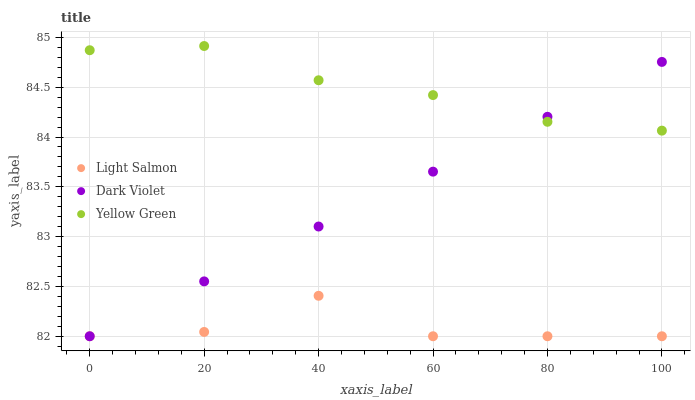Does Light Salmon have the minimum area under the curve?
Answer yes or no. Yes. Does Yellow Green have the maximum area under the curve?
Answer yes or no. Yes. Does Dark Violet have the minimum area under the curve?
Answer yes or no. No. Does Dark Violet have the maximum area under the curve?
Answer yes or no. No. Is Dark Violet the smoothest?
Answer yes or no. Yes. Is Light Salmon the roughest?
Answer yes or no. Yes. Is Yellow Green the smoothest?
Answer yes or no. No. Is Yellow Green the roughest?
Answer yes or no. No. Does Light Salmon have the lowest value?
Answer yes or no. Yes. Does Yellow Green have the lowest value?
Answer yes or no. No. Does Yellow Green have the highest value?
Answer yes or no. Yes. Does Dark Violet have the highest value?
Answer yes or no. No. Is Light Salmon less than Yellow Green?
Answer yes or no. Yes. Is Yellow Green greater than Light Salmon?
Answer yes or no. Yes. Does Light Salmon intersect Dark Violet?
Answer yes or no. Yes. Is Light Salmon less than Dark Violet?
Answer yes or no. No. Is Light Salmon greater than Dark Violet?
Answer yes or no. No. Does Light Salmon intersect Yellow Green?
Answer yes or no. No. 